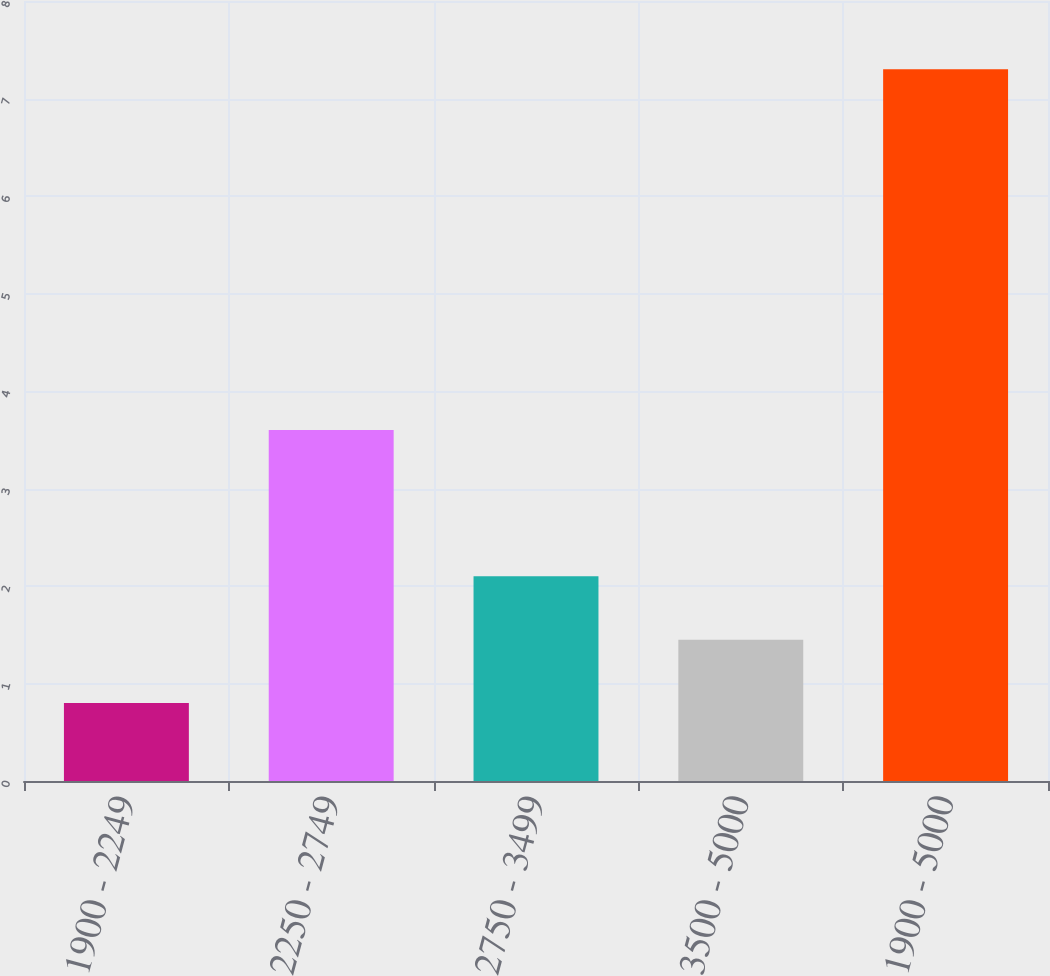<chart> <loc_0><loc_0><loc_500><loc_500><bar_chart><fcel>1900 - 2249<fcel>2250 - 2749<fcel>2750 - 3499<fcel>3500 - 5000<fcel>1900 - 5000<nl><fcel>0.8<fcel>3.6<fcel>2.1<fcel>1.45<fcel>7.3<nl></chart> 